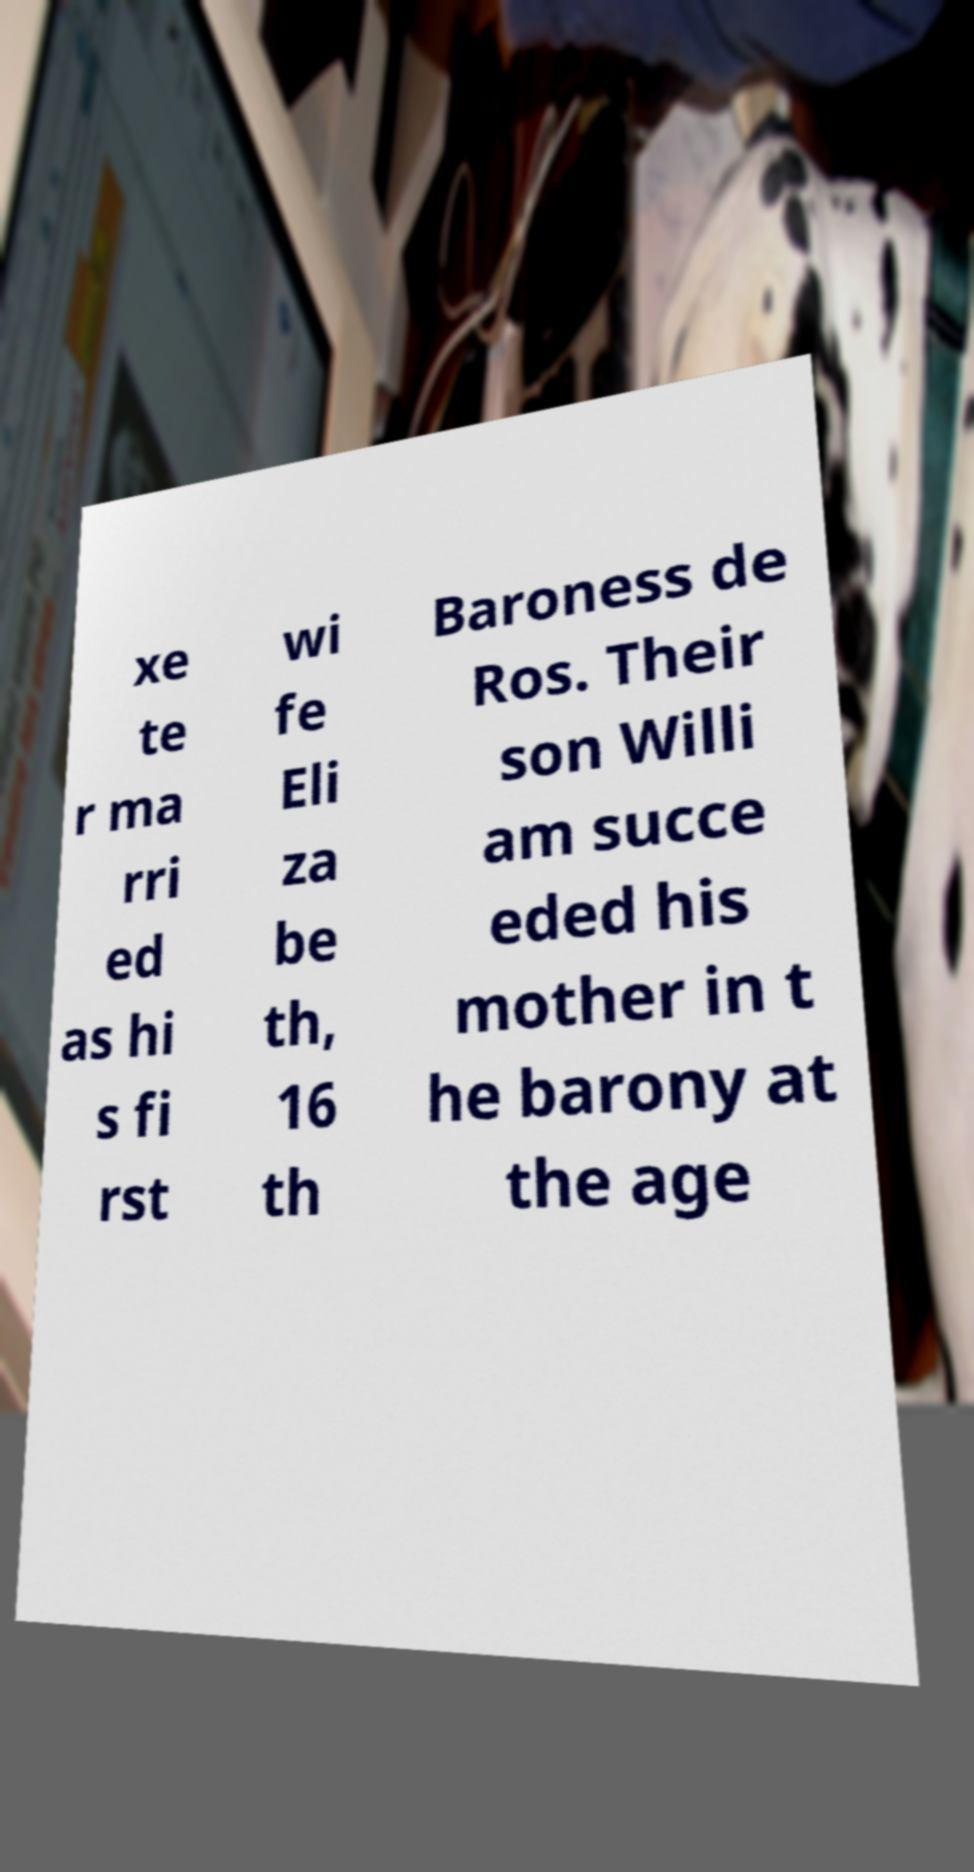Please read and relay the text visible in this image. What does it say? xe te r ma rri ed as hi s fi rst wi fe Eli za be th, 16 th Baroness de Ros. Their son Willi am succe eded his mother in t he barony at the age 